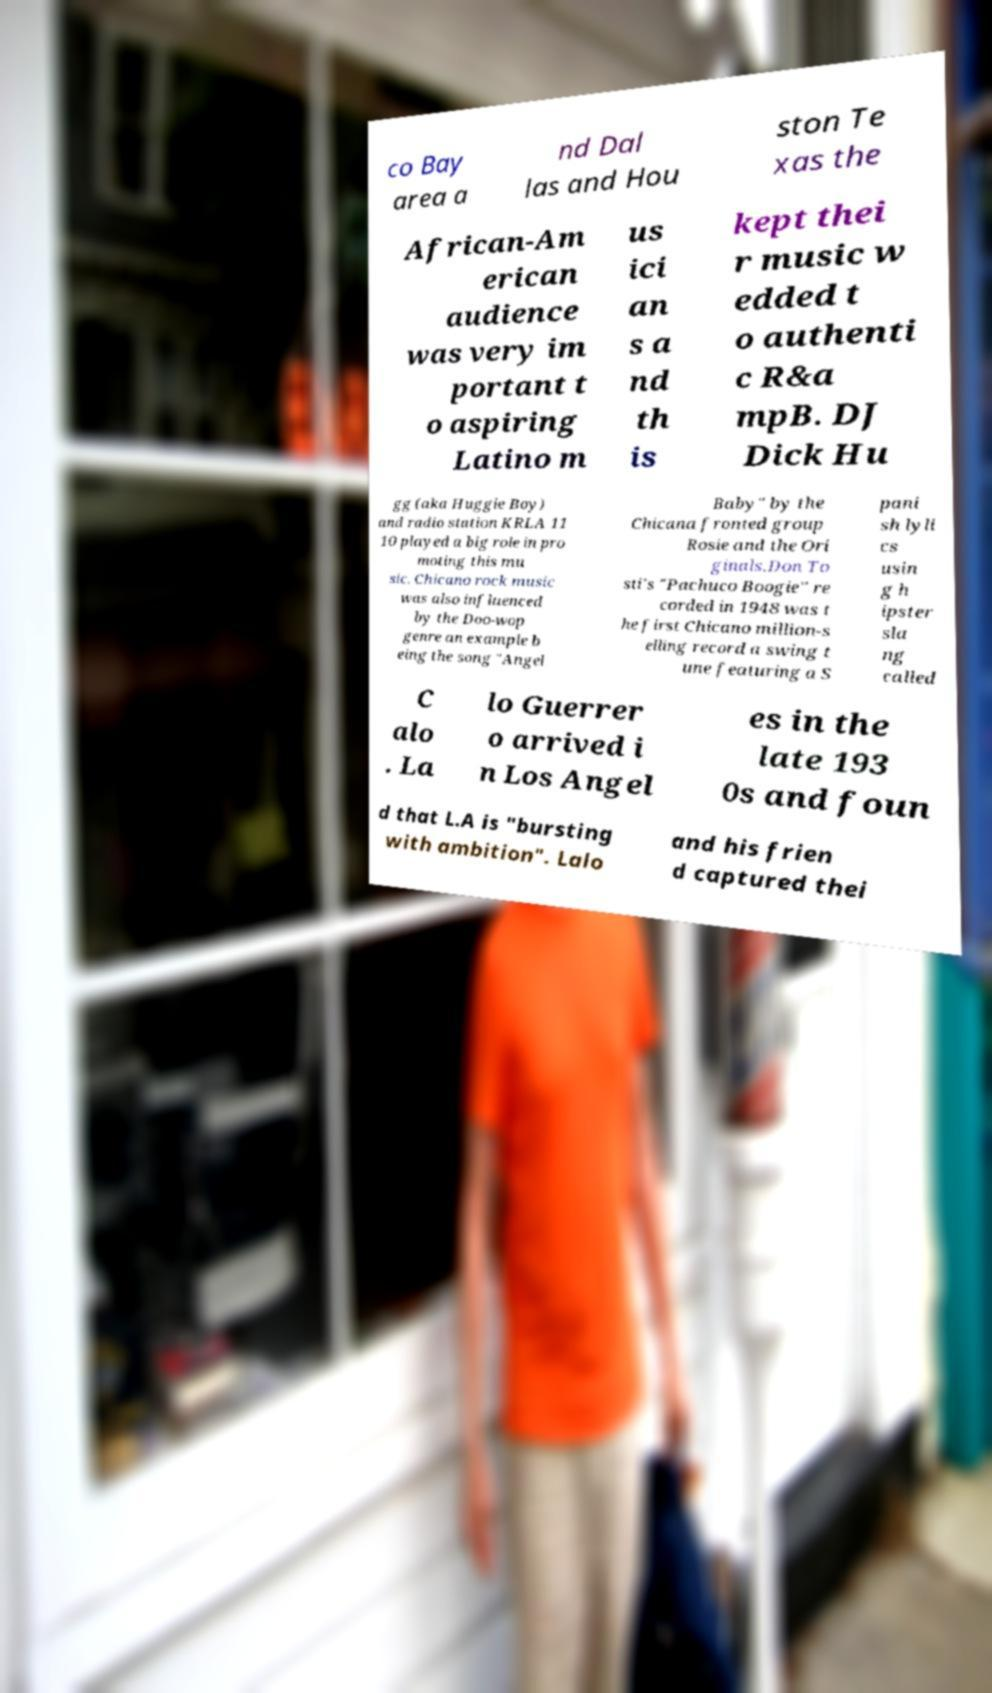Could you extract and type out the text from this image? co Bay area a nd Dal las and Hou ston Te xas the African-Am erican audience was very im portant t o aspiring Latino m us ici an s a nd th is kept thei r music w edded t o authenti c R&a mpB. DJ Dick Hu gg (aka Huggie Boy) and radio station KRLA 11 10 played a big role in pro moting this mu sic. Chicano rock music was also influenced by the Doo-wop genre an example b eing the song "Angel Baby" by the Chicana fronted group Rosie and the Ori ginals.Don To sti's "Pachuco Boogie" re corded in 1948 was t he first Chicano million-s elling record a swing t une featuring a S pani sh lyli cs usin g h ipster sla ng called C alo . La lo Guerrer o arrived i n Los Angel es in the late 193 0s and foun d that L.A is "bursting with ambition". Lalo and his frien d captured thei 